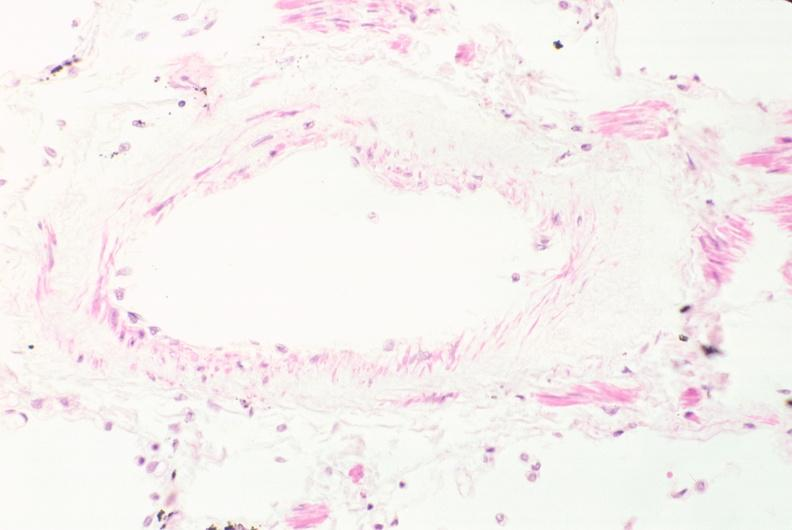what is present?
Answer the question using a single word or phrase. Respiratory 